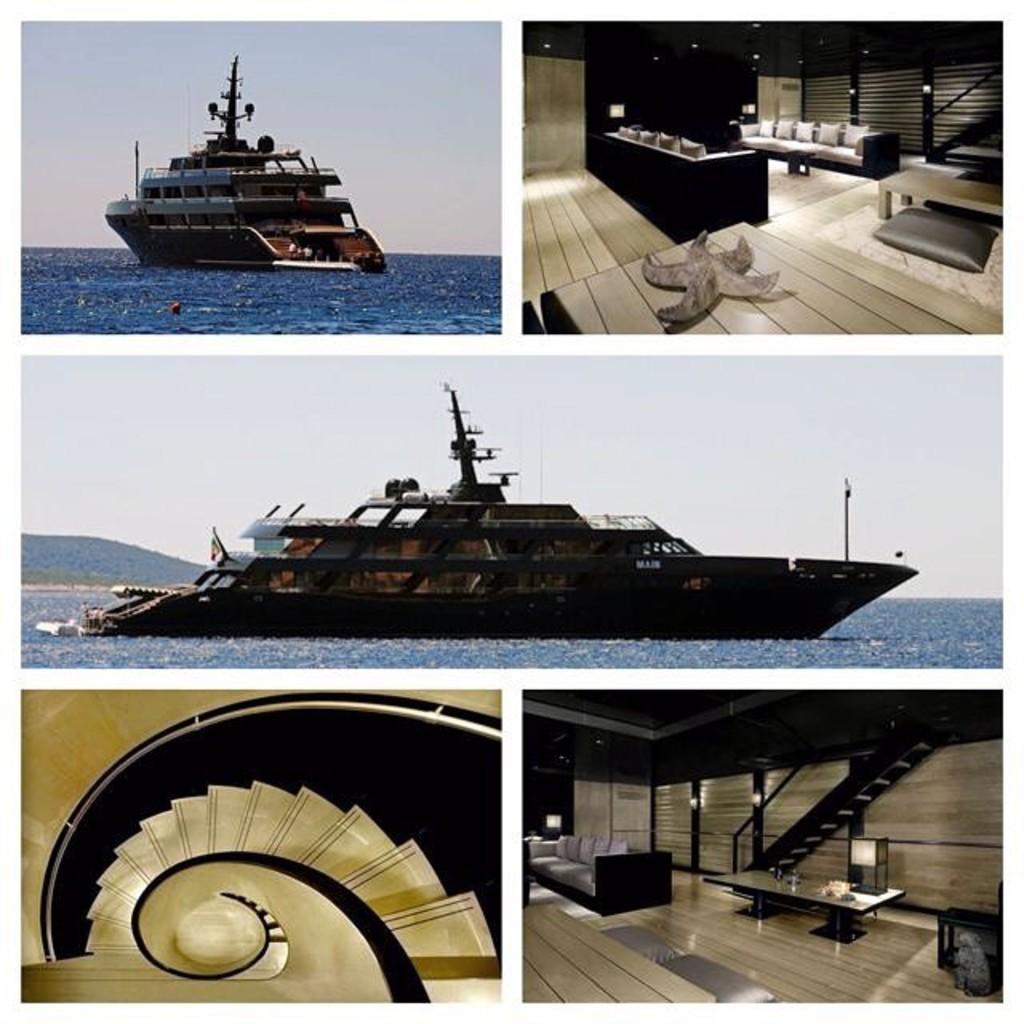In one or two sentences, can you explain what this image depicts? This is collage picture,we can see ship on the water,sky and floor and we can see pillows on sofa and some objects on table. 